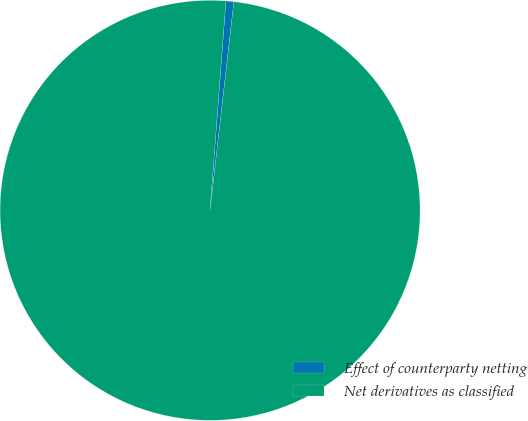<chart> <loc_0><loc_0><loc_500><loc_500><pie_chart><fcel>Effect of counterparty netting<fcel>Net derivatives as classified<nl><fcel>0.61%<fcel>99.39%<nl></chart> 